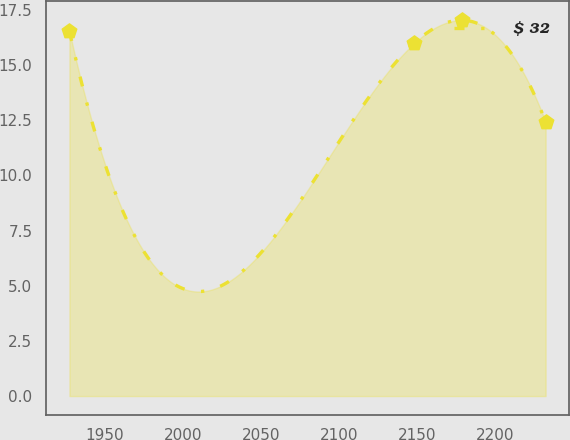Convert chart. <chart><loc_0><loc_0><loc_500><loc_500><line_chart><ecel><fcel>$ 32<nl><fcel>1927.46<fcel>16.54<nl><fcel>2148.19<fcel>16<nl><fcel>2178.67<fcel>17.04<nl><fcel>2232.26<fcel>12.43<nl></chart> 